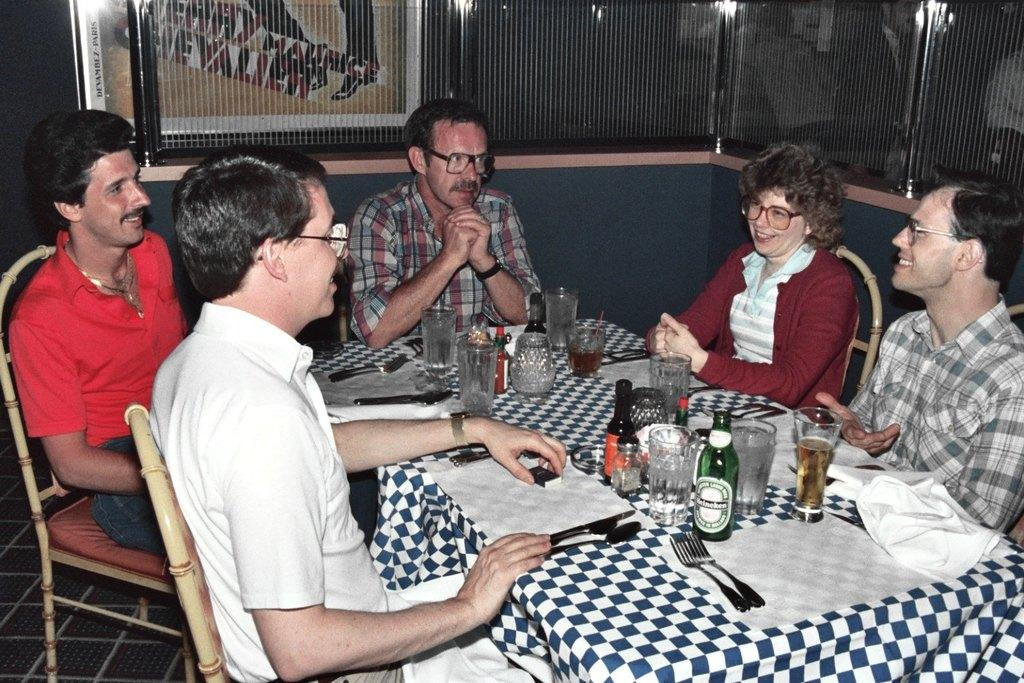How many people are in the image? There is a group of persons in the image. What are the persons doing in the image? The persons are sitting on chairs. What objects are on the table in the image? There are bottles, glasses, spoons, and forks on the table. What type of key is used to unlock the notebook in the image? There is no key or notebook present in the image. How does the balance of the forks on the table affect the stability of the glasses? There is no mention of balance or stability in the image; the forks and glasses are simply present on the table. 